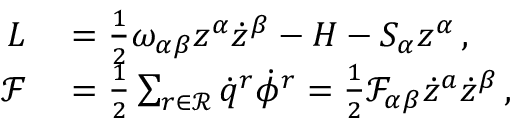Convert formula to latex. <formula><loc_0><loc_0><loc_500><loc_500>\begin{array} { r l } { L } & = \frac { 1 } { 2 } \omega _ { \alpha \beta } z ^ { \alpha } \dot { z } ^ { \beta } - H - S _ { \alpha } { z } ^ { \alpha } \, , } \\ { \mathcal { F } } & = \frac { 1 } { 2 } \sum _ { r \in \mathcal { R } } \dot { q } ^ { r } \dot { \phi } ^ { r } = \frac { 1 } { 2 } \mathcal { F } _ { \alpha \beta } \dot { z } ^ { a } \dot { z } ^ { \beta } \, , } \end{array}</formula> 